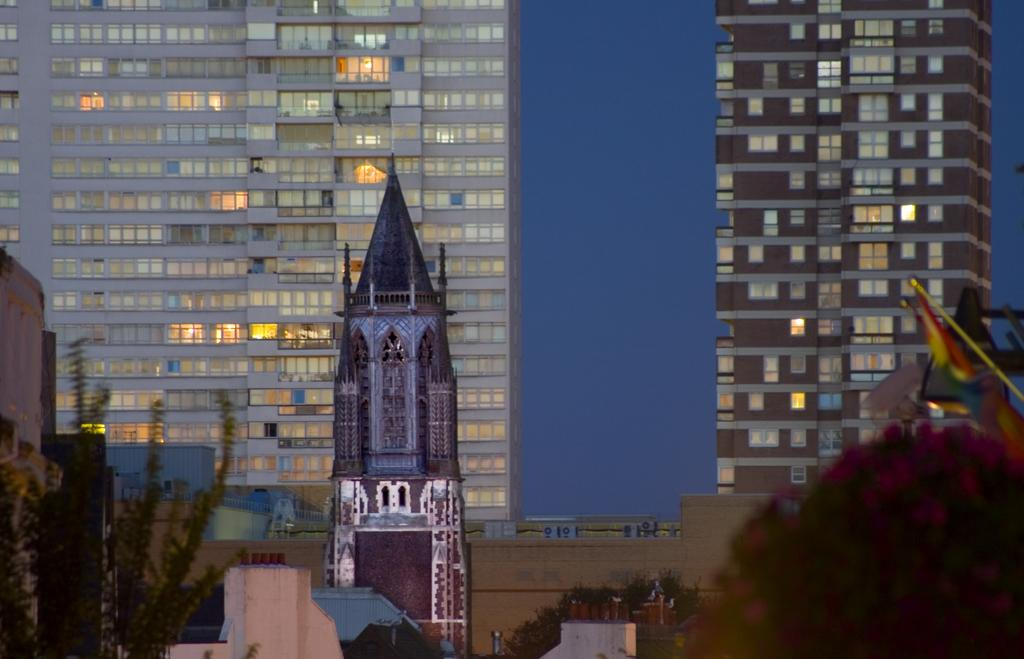What type of building is located in the front of the image? There is a tower building in the front of the image. What can be seen in the background of the image? There are huge glass buildings visible in the background of the image. What type of horn can be heard coming from the bears in the image? There are no bears or horns present in the image. 